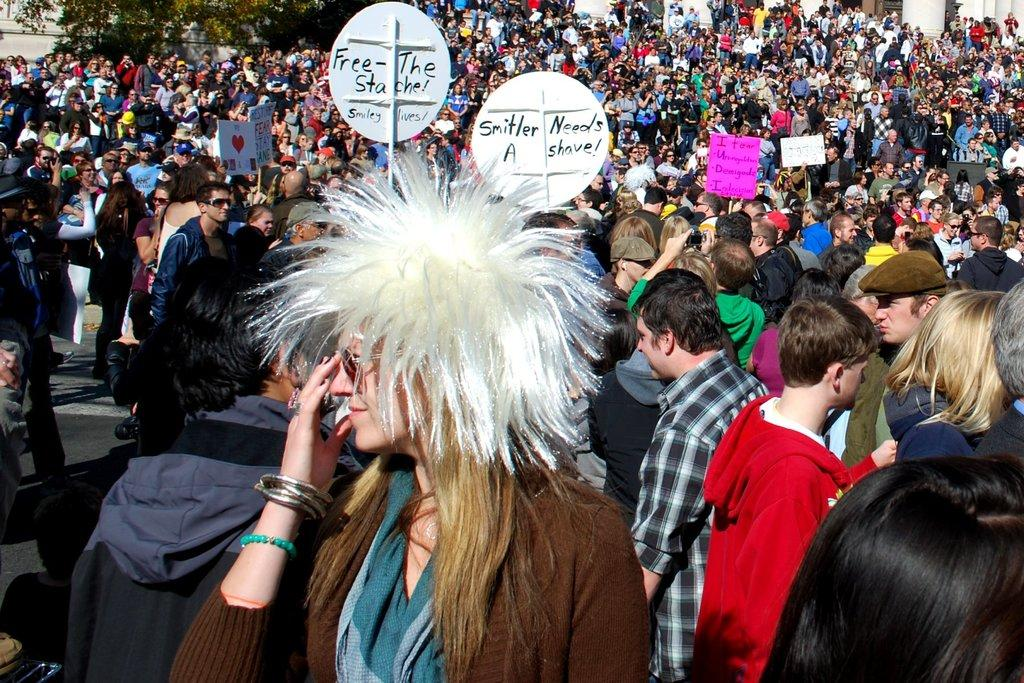What is the main subject of the image? The main subject of the image is a large crowd of people. Can you describe any specific actions or behaviors of the people in the crowd? Some people in the crowd are holding boards with text. How many pockets can be seen on the people in the image? There is no information about pockets on the people in the image, so it cannot be determined. 